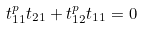Convert formula to latex. <formula><loc_0><loc_0><loc_500><loc_500>t _ { 1 1 } ^ { p } t _ { 2 1 } + t _ { 1 2 } ^ { p } t _ { 1 1 } = 0</formula> 